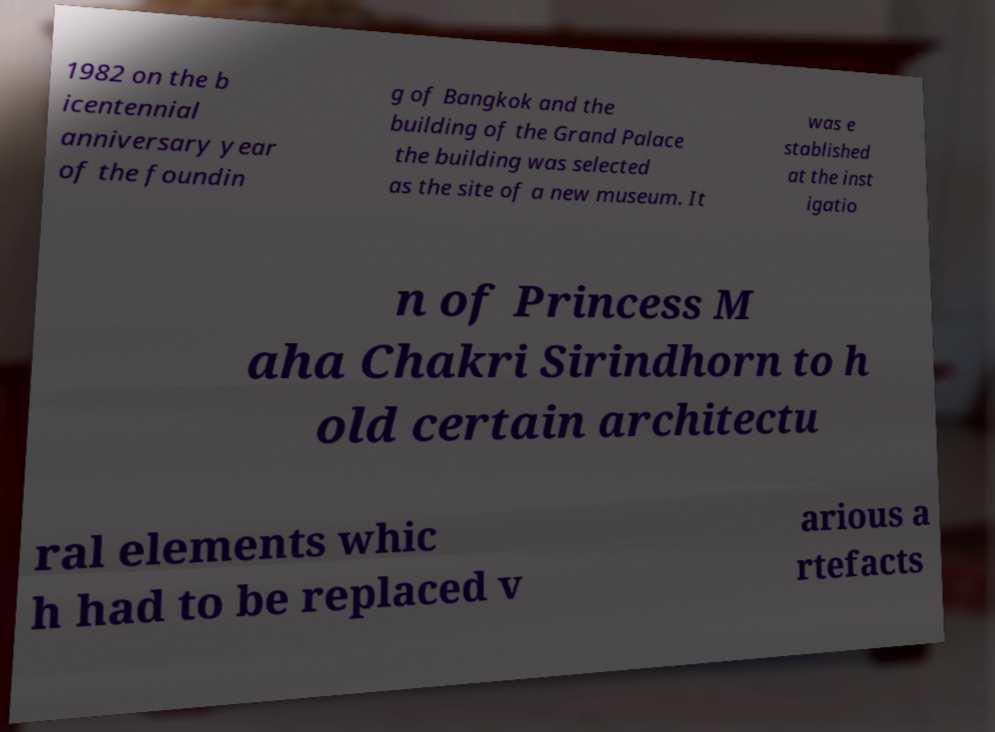Can you read and provide the text displayed in the image?This photo seems to have some interesting text. Can you extract and type it out for me? 1982 on the b icentennial anniversary year of the foundin g of Bangkok and the building of the Grand Palace the building was selected as the site of a new museum. It was e stablished at the inst igatio n of Princess M aha Chakri Sirindhorn to h old certain architectu ral elements whic h had to be replaced v arious a rtefacts 